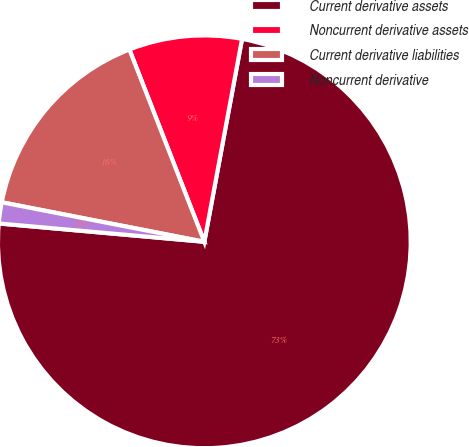<chart> <loc_0><loc_0><loc_500><loc_500><pie_chart><fcel>Current derivative assets<fcel>Noncurrent derivative assets<fcel>Current derivative liabilities<fcel>Noncurrent derivative<nl><fcel>73.49%<fcel>8.84%<fcel>16.02%<fcel>1.65%<nl></chart> 